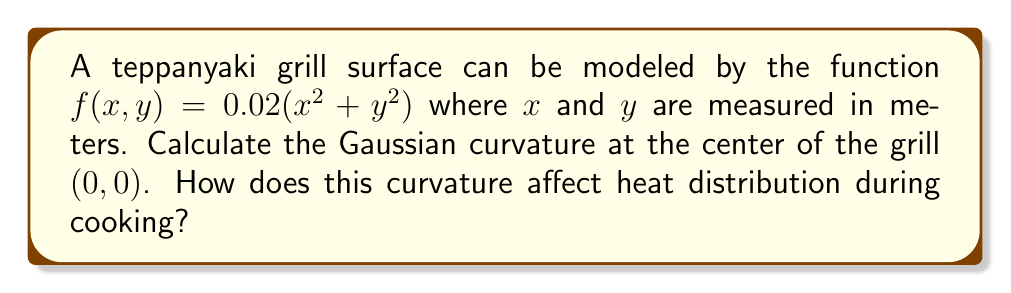Give your solution to this math problem. To analyze the curvature of the teppanyaki grill surface, we'll use differential geometry:

1) The Gaussian curvature K is given by:
   $$K = \frac{f_{xx}f_{yy} - f_{xy}^2}{(1 + f_x^2 + f_y^2)^2}$$

2) Calculate partial derivatives:
   $f_x = 0.04x$
   $f_y = 0.04y$
   $f_{xx} = 0.04$
   $f_{yy} = 0.04$
   $f_{xy} = 0$

3) At the center (0,0):
   $f_x = f_y = 0$
   $f_{xx} = f_{yy} = 0.04$
   $f_{xy} = 0$

4) Substitute into the Gaussian curvature formula:
   $$K = \frac{(0.04)(0.04) - 0^2}{(1 + 0^2 + 0^2)^2} = \frac{0.0016}{1} = 0.0016$$

5) The positive Gaussian curvature indicates that the surface is dome-shaped at the center.

6) For cooking, this slight curvature helps:
   - Oil and juices flow towards the edges
   - Heat distributes more evenly from the center
   - Easier to maneuver utensils on the curved surface

This curvature enhances the teppanyaki cooking technique by allowing better control of ingredients and heat distribution.
Answer: $K = 0.0016$ m^(-2); dome-shaped center improves cooking control and heat distribution 